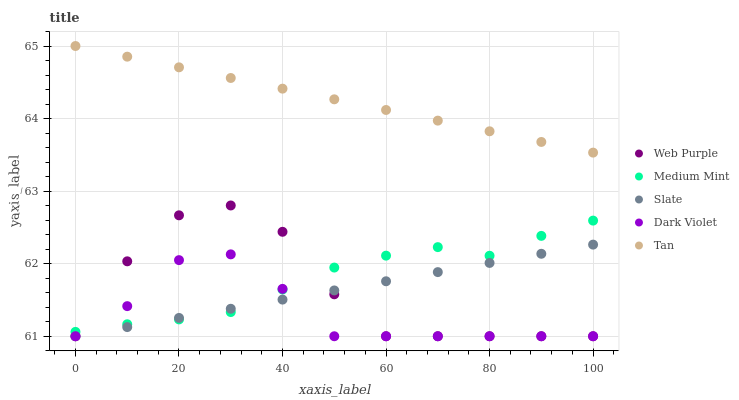Does Dark Violet have the minimum area under the curve?
Answer yes or no. Yes. Does Tan have the maximum area under the curve?
Answer yes or no. Yes. Does Web Purple have the minimum area under the curve?
Answer yes or no. No. Does Web Purple have the maximum area under the curve?
Answer yes or no. No. Is Tan the smoothest?
Answer yes or no. Yes. Is Web Purple the roughest?
Answer yes or no. Yes. Is Web Purple the smoothest?
Answer yes or no. No. Is Tan the roughest?
Answer yes or no. No. Does Web Purple have the lowest value?
Answer yes or no. Yes. Does Tan have the lowest value?
Answer yes or no. No. Does Tan have the highest value?
Answer yes or no. Yes. Does Web Purple have the highest value?
Answer yes or no. No. Is Medium Mint less than Tan?
Answer yes or no. Yes. Is Tan greater than Dark Violet?
Answer yes or no. Yes. Does Slate intersect Web Purple?
Answer yes or no. Yes. Is Slate less than Web Purple?
Answer yes or no. No. Is Slate greater than Web Purple?
Answer yes or no. No. Does Medium Mint intersect Tan?
Answer yes or no. No. 